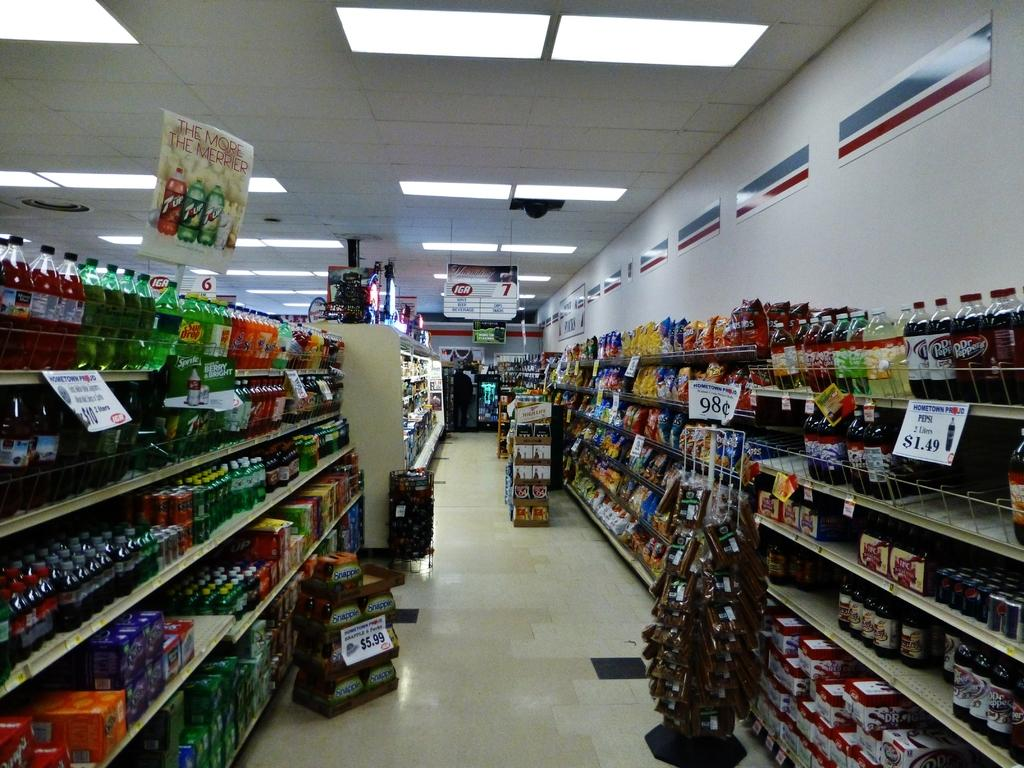<image>
Write a terse but informative summary of the picture. Some bags of chips selling for 98 cents on a shelf in a full grocery store. 